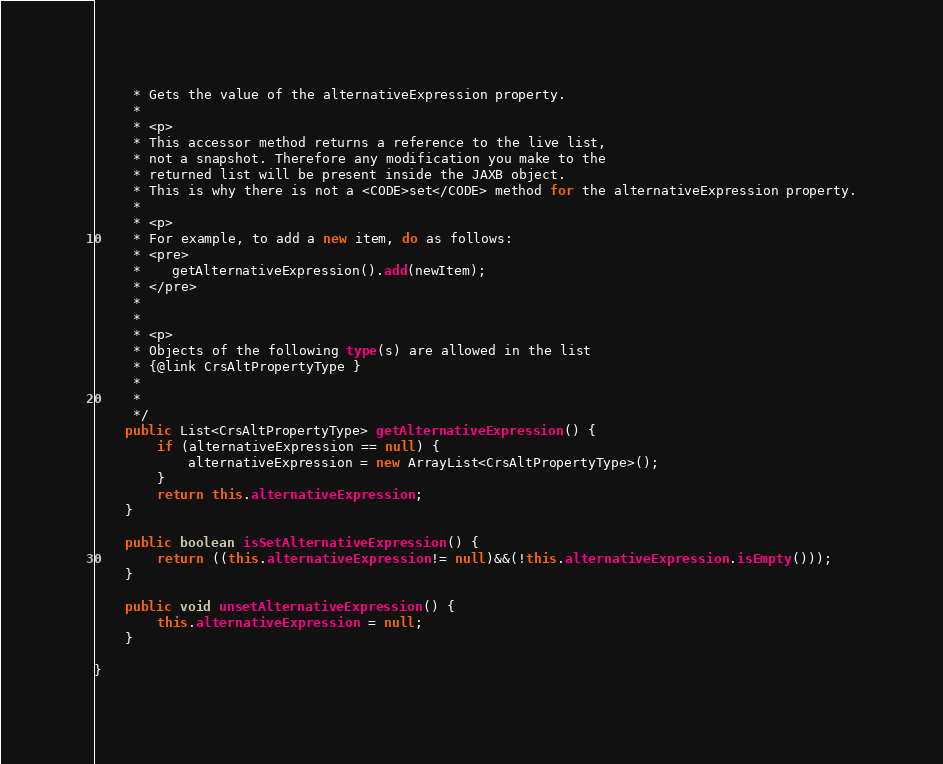Convert code to text. <code><loc_0><loc_0><loc_500><loc_500><_Java_>     * Gets the value of the alternativeExpression property.
     * 
     * <p>
     * This accessor method returns a reference to the live list,
     * not a snapshot. Therefore any modification you make to the
     * returned list will be present inside the JAXB object.
     * This is why there is not a <CODE>set</CODE> method for the alternativeExpression property.
     * 
     * <p>
     * For example, to add a new item, do as follows:
     * <pre>
     *    getAlternativeExpression().add(newItem);
     * </pre>
     * 
     * 
     * <p>
     * Objects of the following type(s) are allowed in the list
     * {@link CrsAltPropertyType }
     * 
     * 
     */
    public List<CrsAltPropertyType> getAlternativeExpression() {
        if (alternativeExpression == null) {
            alternativeExpression = new ArrayList<CrsAltPropertyType>();
        }
        return this.alternativeExpression;
    }

    public boolean isSetAlternativeExpression() {
        return ((this.alternativeExpression!= null)&&(!this.alternativeExpression.isEmpty()));
    }

    public void unsetAlternativeExpression() {
        this.alternativeExpression = null;
    }

}
</code> 